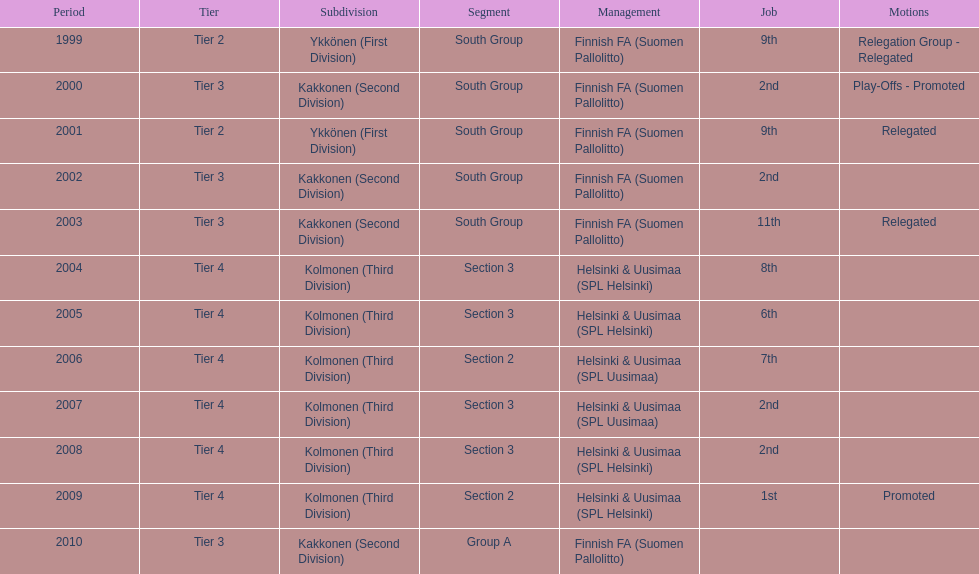How many times were they in tier 3? 4. 